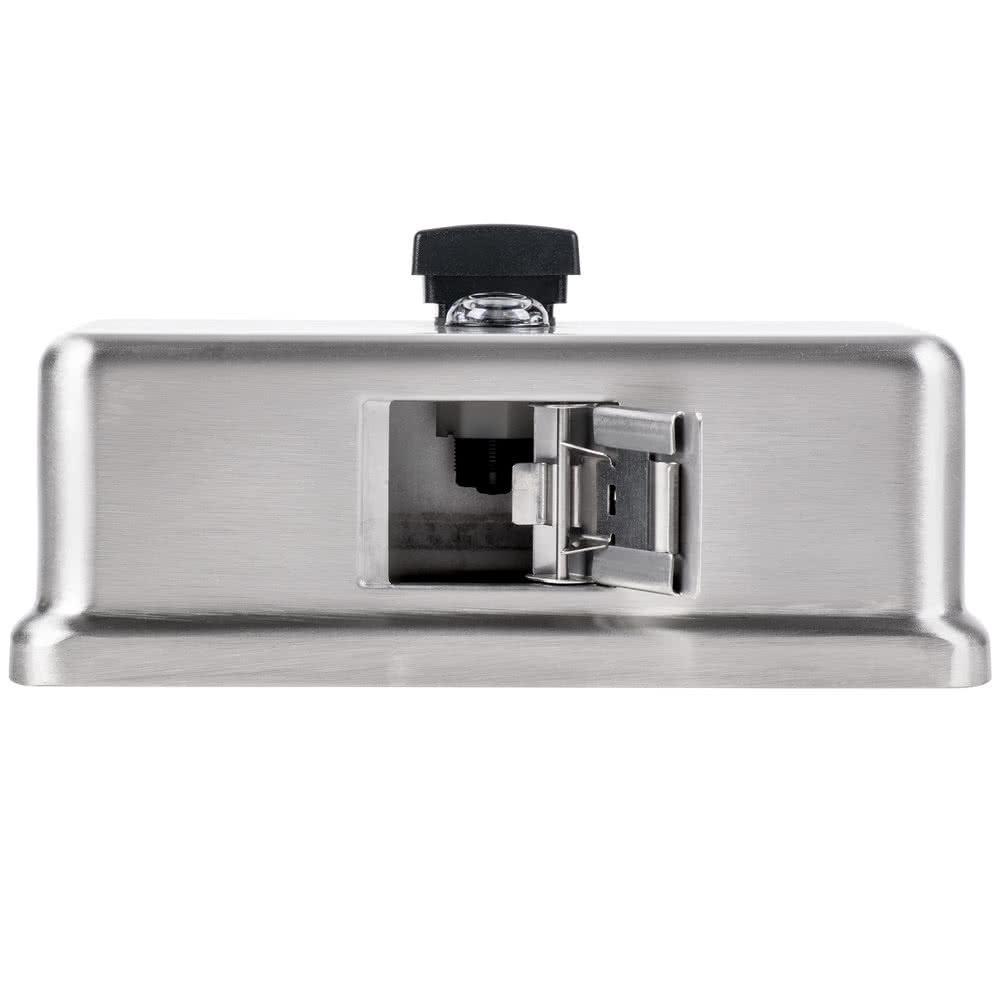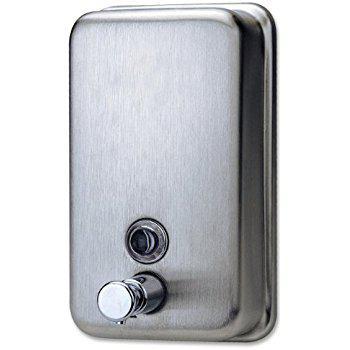The first image is the image on the left, the second image is the image on the right. Examine the images to the left and right. Is the description "The object in the image on the left is turned toward the right." accurate? Answer yes or no. No. 